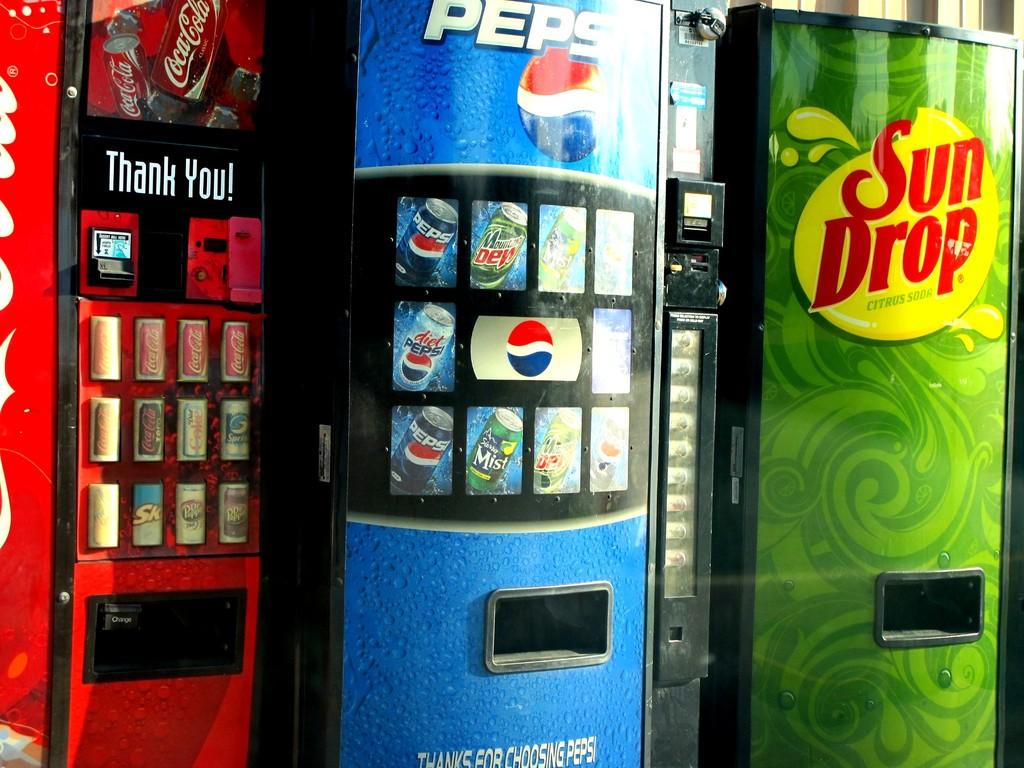What are the brand names on the soda machines?
Provide a succinct answer. Coca-cola, pepsi, sun drop. What nice phrase does the coke machine say?
Provide a short and direct response. Thank you!. 